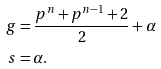Convert formula to latex. <formula><loc_0><loc_0><loc_500><loc_500>g & = \frac { p ^ { n } + p ^ { n - 1 } + 2 } { 2 } + \alpha \\ s & = \alpha .</formula> 